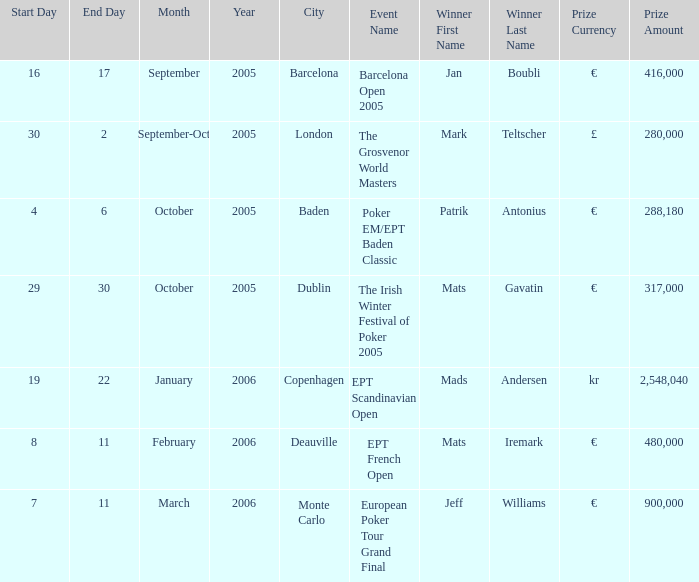Which occurrence awarded a €900,000 reward? European Poker Tour Grand Final. 